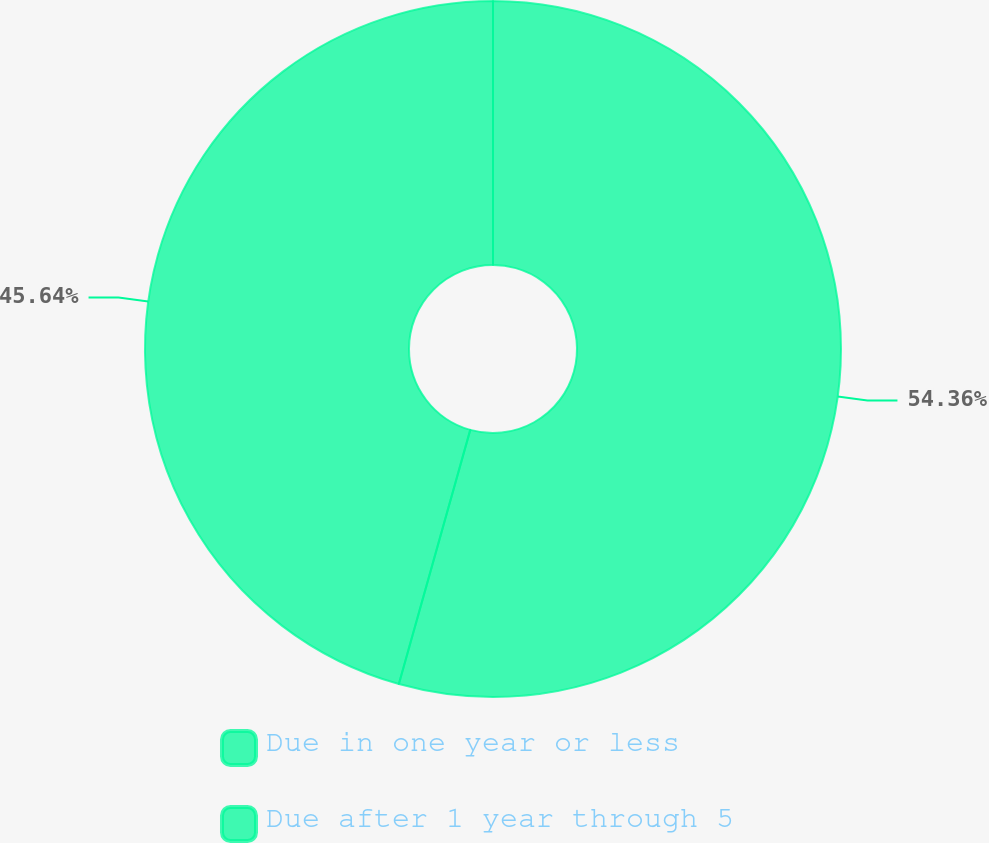Convert chart to OTSL. <chart><loc_0><loc_0><loc_500><loc_500><pie_chart><fcel>Due in one year or less<fcel>Due after 1 year through 5<nl><fcel>54.36%<fcel>45.64%<nl></chart> 